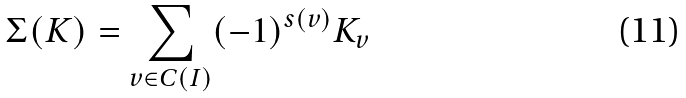<formula> <loc_0><loc_0><loc_500><loc_500>\Sigma ( K ) = \sum _ { v \in C ( I ) } ( - 1 ) ^ { s ( v ) } K _ { v } \</formula> 